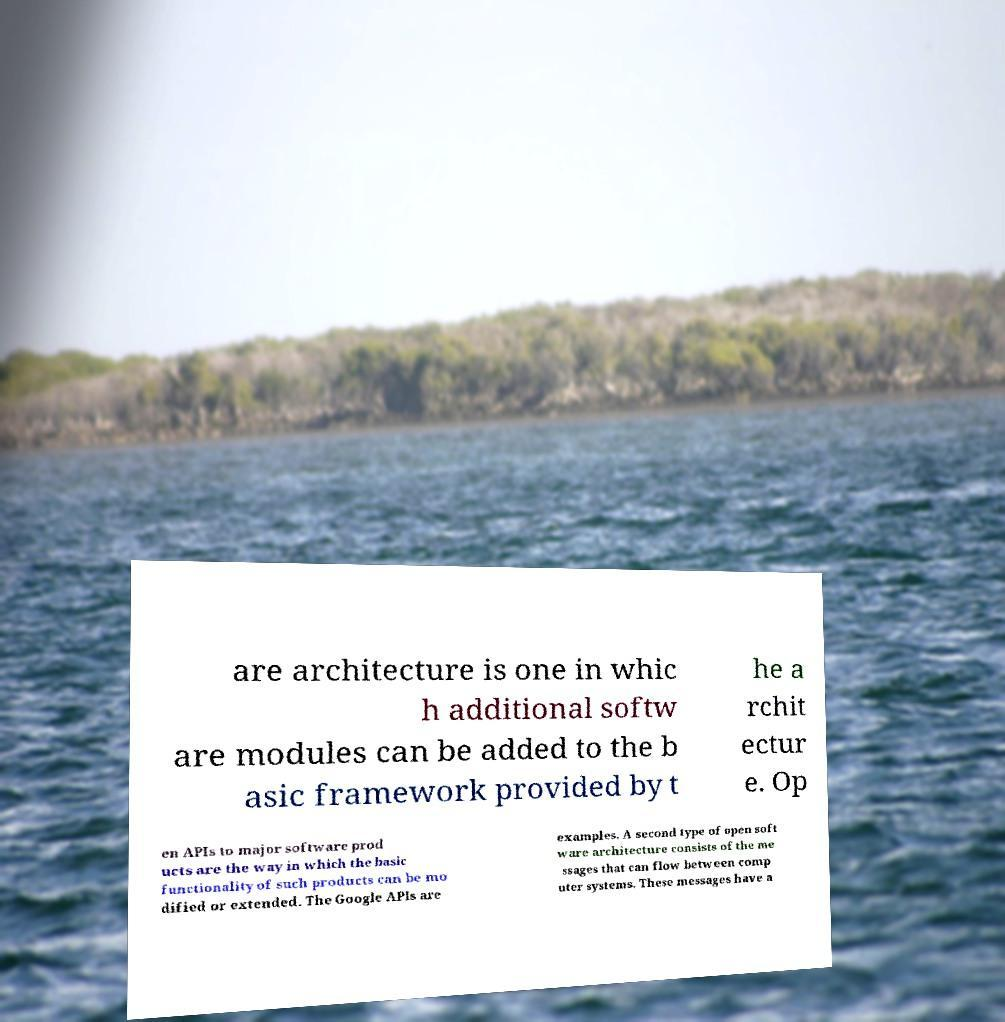Please identify and transcribe the text found in this image. are architecture is one in whic h additional softw are modules can be added to the b asic framework provided by t he a rchit ectur e. Op en APIs to major software prod ucts are the way in which the basic functionality of such products can be mo dified or extended. The Google APIs are examples. A second type of open soft ware architecture consists of the me ssages that can flow between comp uter systems. These messages have a 